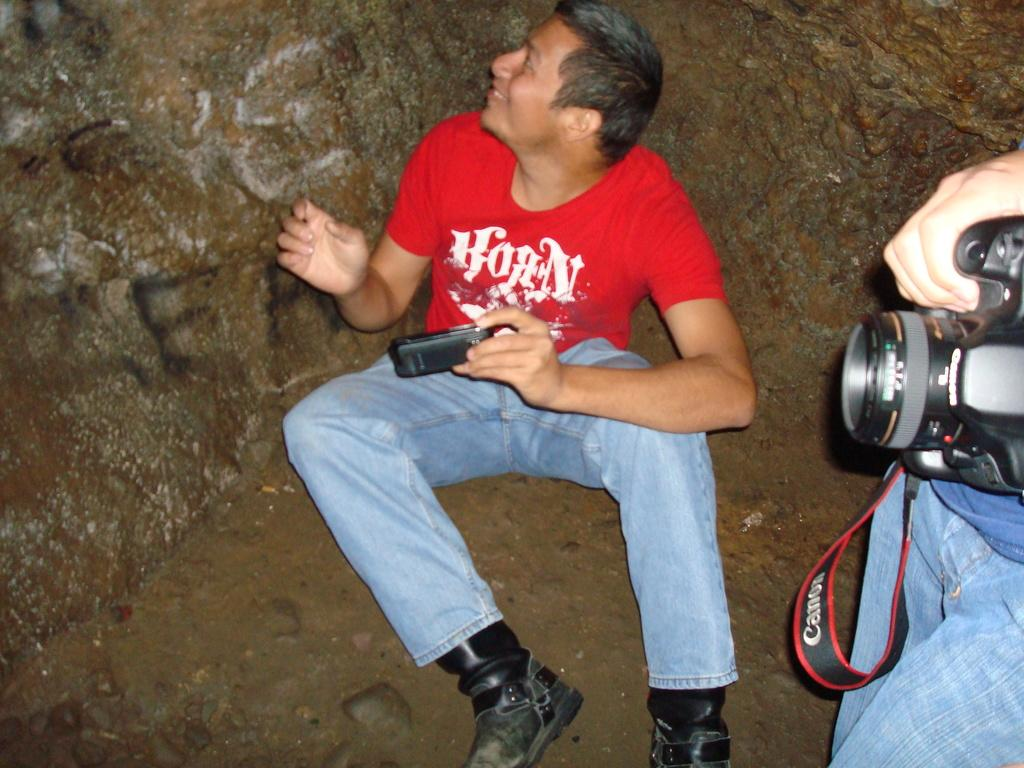What is the man in the image doing? The man is sitting on the floor in the image. What object is the man holding? The man is holding a mobile phone. Can you describe the other person in the image? The other person is near the man and is holding a camera. What type of corn treatment is the man applying to the grandfather in the image? There is no grandfather or corn treatment present in the image. 